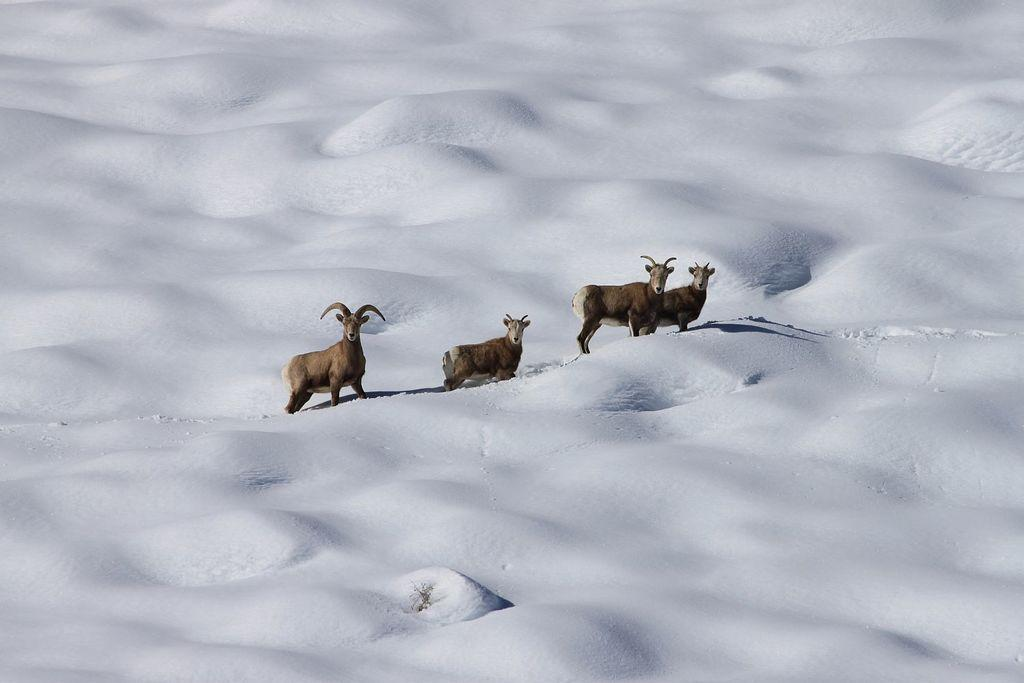What animals are present in the image? There are goats in the image. What type of terrain can be seen in the image? The goats are standing on snow. What sound can be heard coming from the goats in the image? There is no sound present in the image, so it cannot be determined what sound the goats might be making. 